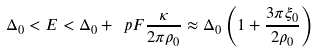Convert formula to latex. <formula><loc_0><loc_0><loc_500><loc_500>\Delta _ { 0 } < E < \Delta _ { 0 } + \ p F \frac { \kappa } { 2 \pi \rho _ { 0 } } \approx \Delta _ { 0 } \left ( 1 + \frac { 3 \pi \xi _ { 0 } } { 2 \rho _ { 0 } } \right )</formula> 